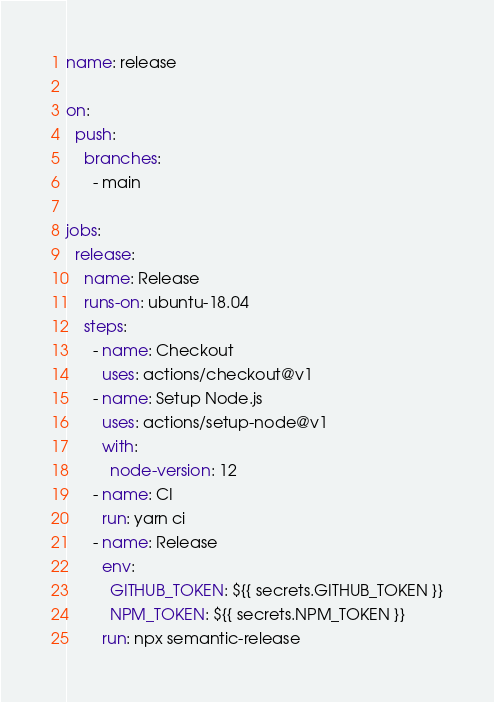Convert code to text. <code><loc_0><loc_0><loc_500><loc_500><_YAML_>name: release

on:
  push:
    branches:
      - main

jobs:
  release:
    name: Release
    runs-on: ubuntu-18.04
    steps:
      - name: Checkout
        uses: actions/checkout@v1
      - name: Setup Node.js
        uses: actions/setup-node@v1
        with:
          node-version: 12
      - name: CI
        run: yarn ci
      - name: Release
        env:
          GITHUB_TOKEN: ${{ secrets.GITHUB_TOKEN }}
          NPM_TOKEN: ${{ secrets.NPM_TOKEN }}
        run: npx semantic-release
</code> 